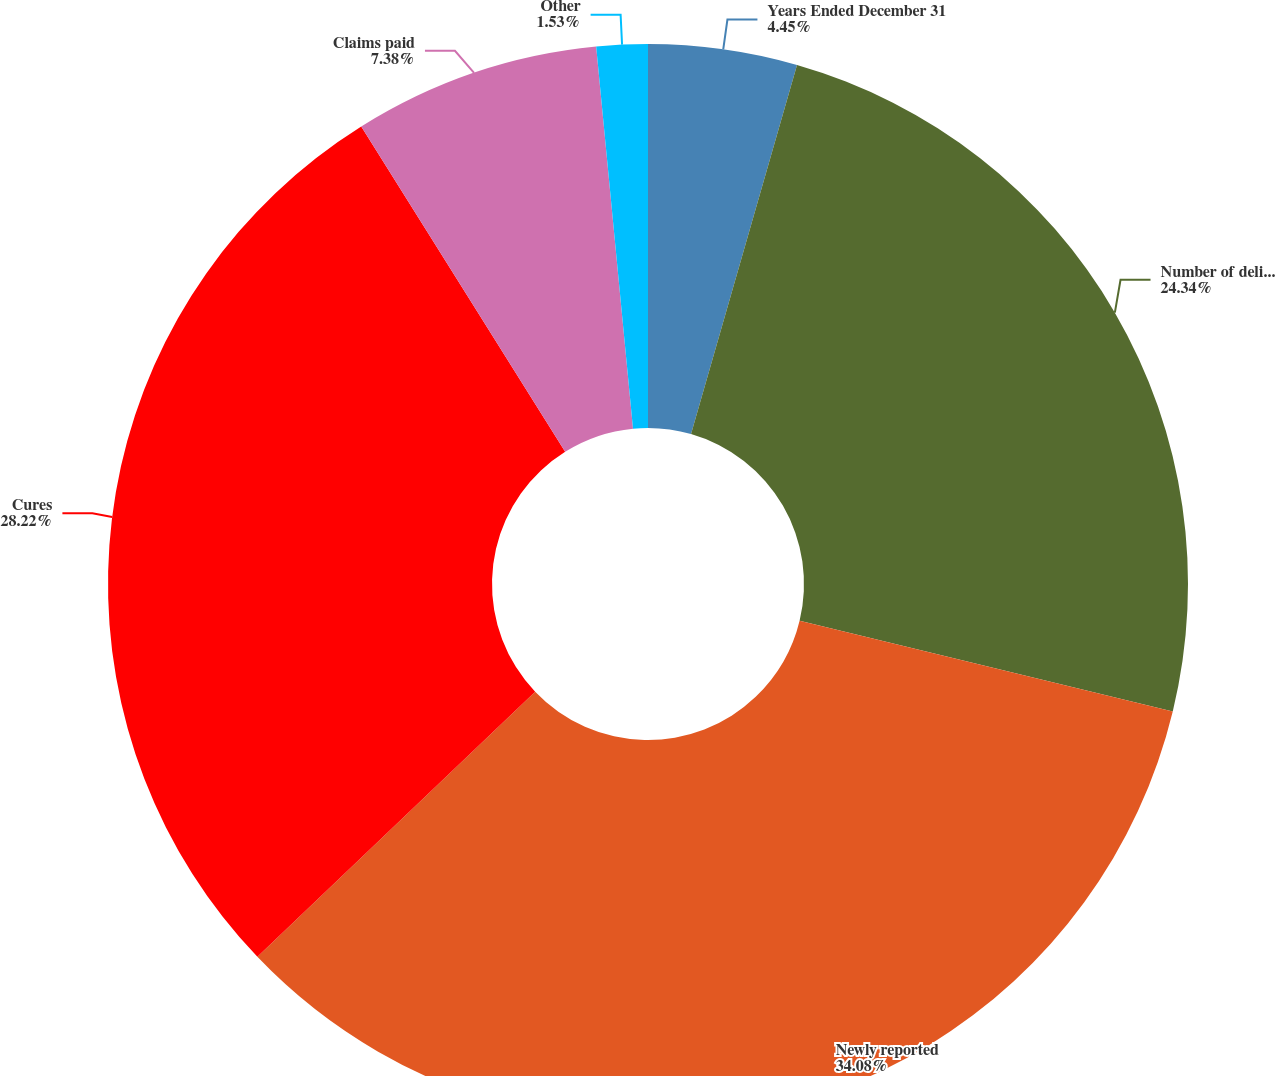Convert chart. <chart><loc_0><loc_0><loc_500><loc_500><pie_chart><fcel>Years Ended December 31<fcel>Number of delinquencies at the<fcel>Newly reported<fcel>Cures<fcel>Claims paid<fcel>Other<nl><fcel>4.45%<fcel>24.34%<fcel>34.08%<fcel>28.22%<fcel>7.38%<fcel>1.53%<nl></chart> 